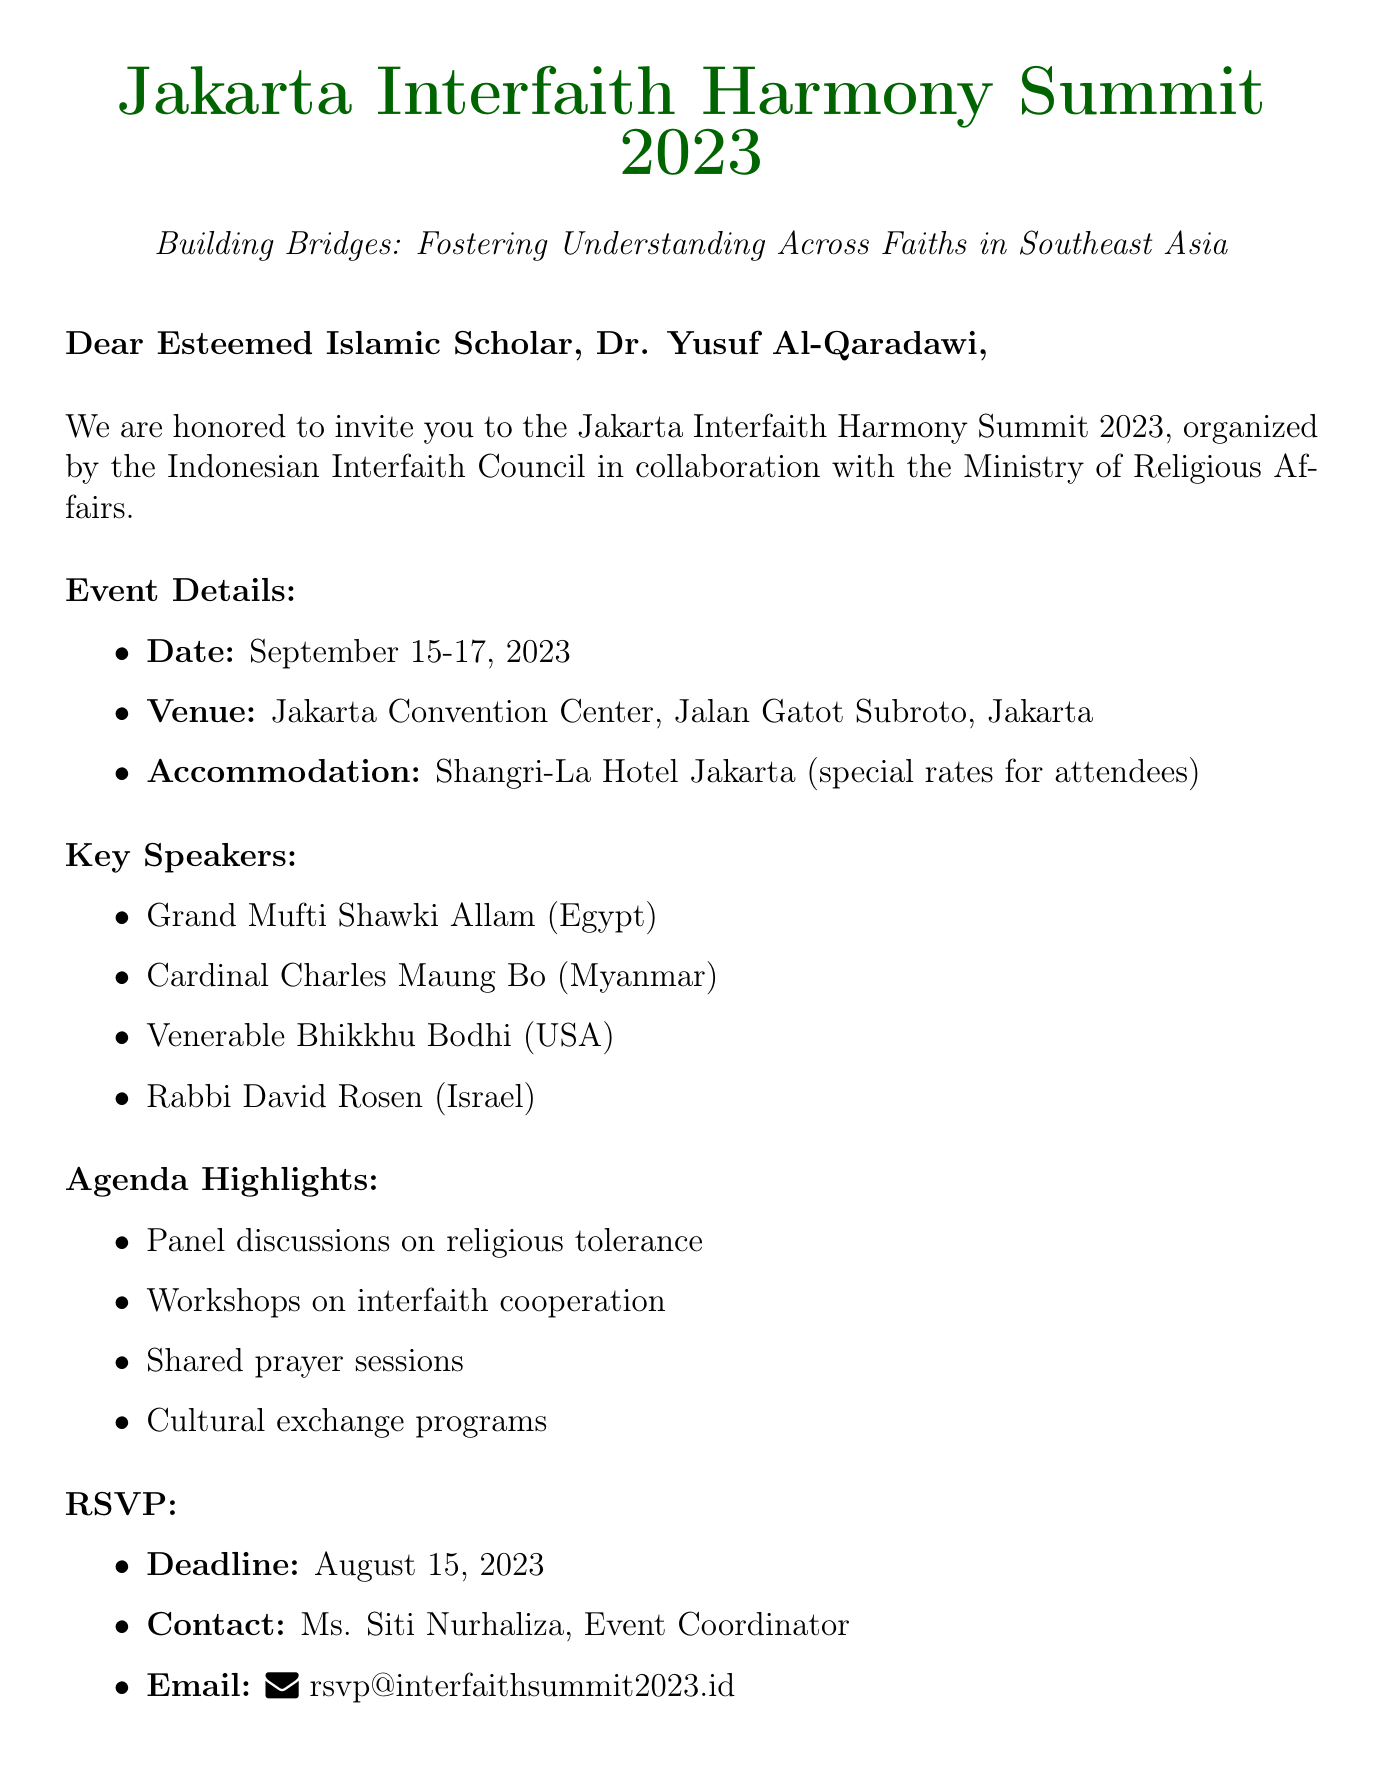What is the name of the event? The name of the event is mentioned in the invitation, which is the Jakarta Interfaith Harmony Summit 2023.
Answer: Jakarta Interfaith Harmony Summit 2023 When will the event take place? The document specifies that the event will take place from September 15 to September 17, 2023.
Answer: September 15-17, 2023 Who is the recipient of the invitation? The recipient's name is stated at the beginning of the document, which is Dr. Yusuf Al-Qaradawi.
Answer: Dr. Yusuf Al-Qaradawi What is one of the agenda highlights? The document lists several agenda highlights, one of which is panel discussions on religious tolerance.
Answer: Panel discussions on religious tolerance What is the RSVP deadline? The RSVP deadline is explicitly mentioned in the document as August 15, 2023.
Answer: August 15, 2023 What type of accommodation is provided? The document states that accommodation is available at the Shangri-La Hotel Jakarta.
Answer: Shangri-La Hotel Jakarta Who can be contacted for RSVP? The invitation provides the name of the event coordinator for RSVP, which is Ms. Siti Nurhaliza.
Answer: Ms. Siti Nurhaliza What is the theme of the summit? The theme of the summit is given in the document as Building Bridges: Fostering Understanding Across Faiths in Southeast Asia.
Answer: Building Bridges: Fostering Understanding Across Faiths in Southeast Asia What special requests are mentioned in the document? The document asks the recipient to inform them of any dietary restrictions or accessibility requirements.
Answer: Dietary restrictions or accessibility requirements 